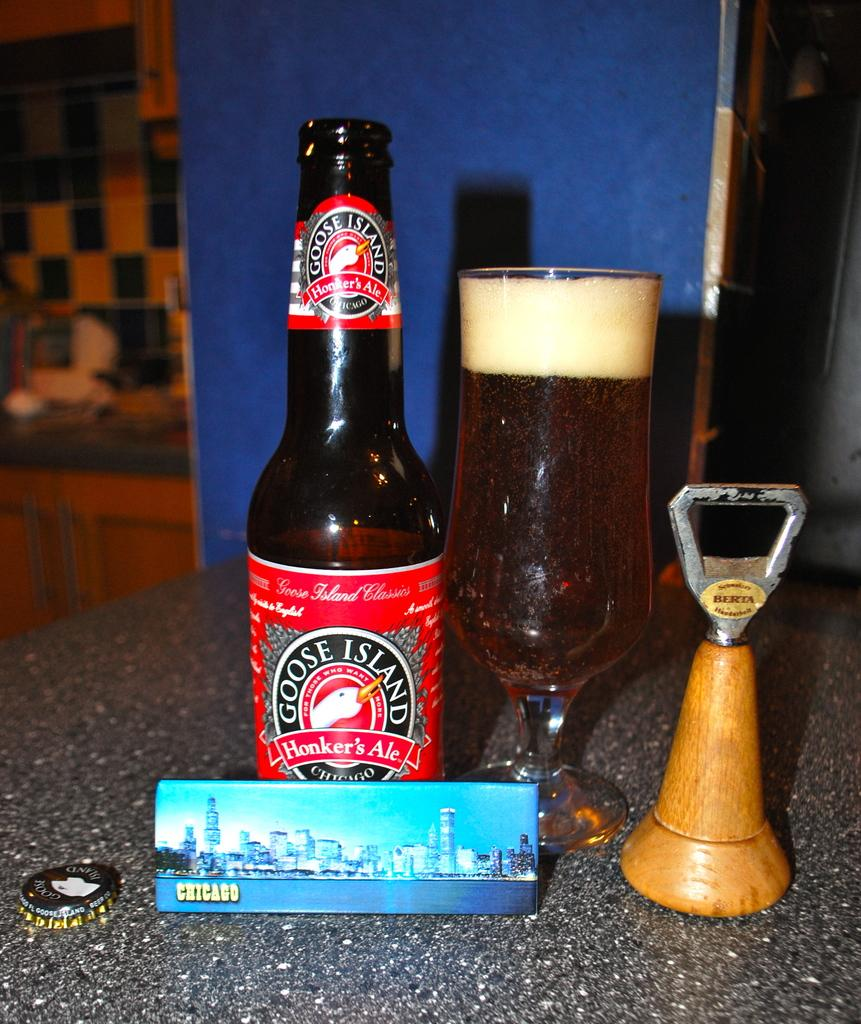What is one of the items on the table in the image? There is a bottle in the image. What is in the glass on the table in the image? There is a glass filled with alcohol in the image. What tool is used to open the bottle in the image? There is an opener in the image. What type of paper item is present on the table in the image? There is a card in the image. Can you describe the location of these items? The table is mentioned as the location for these items. What is the status of the bottle's cap in the image? The cap of the bottle is visible in the image. What type of credit is being offered on the shelf in the image? There is no shelf or credit mentioned in the image; it only features a bottle, glass, opener, card, and table. What is the porter doing in the image? There is no porter present in the image. 